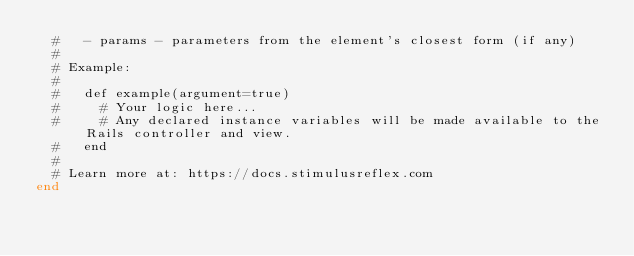Convert code to text. <code><loc_0><loc_0><loc_500><loc_500><_Ruby_>  #   - params - parameters from the element's closest form (if any)
  #
  # Example:
  #
  #   def example(argument=true)
  #     # Your logic here...
  #     # Any declared instance variables will be made available to the Rails controller and view.
  #   end
  #
  # Learn more at: https://docs.stimulusreflex.com
end
</code> 